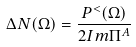<formula> <loc_0><loc_0><loc_500><loc_500>\Delta N ( \Omega ) = \frac { P ^ { < } ( \Omega ) } { 2 I m \Pi ^ { A } }</formula> 